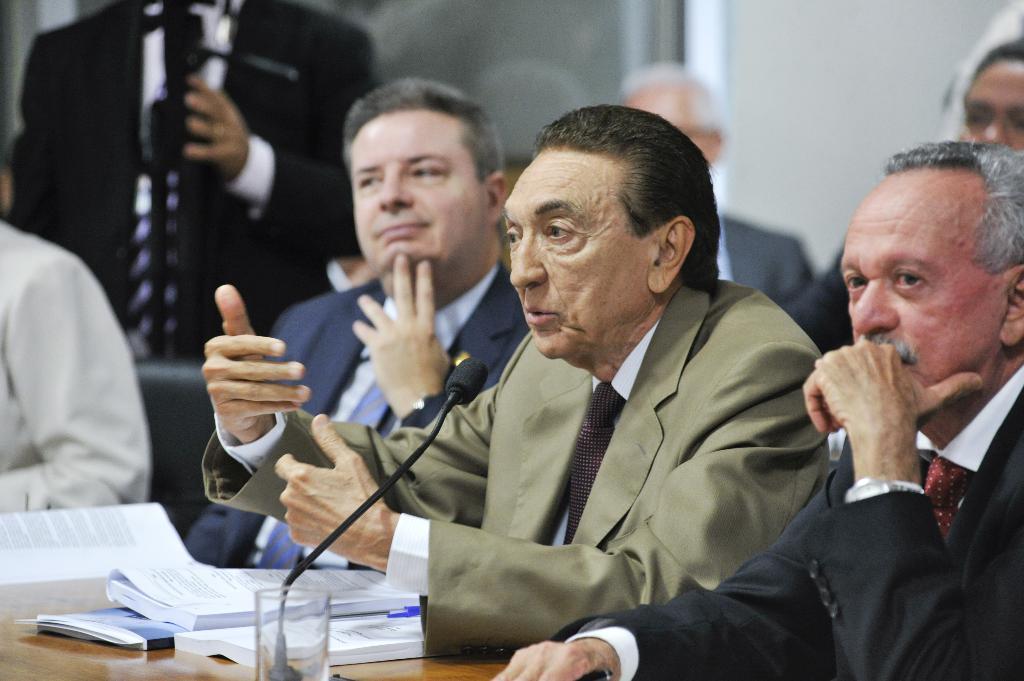Describe this image in one or two sentences. In this picture I can see people sitting. I can see the microphone. I can see glass, books on the table. 